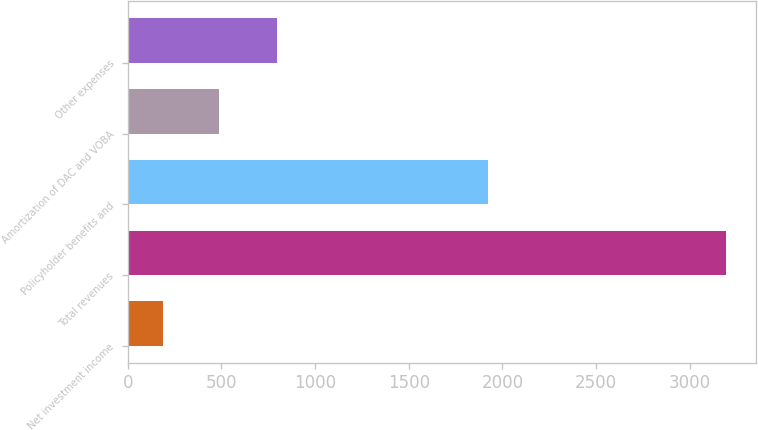Convert chart to OTSL. <chart><loc_0><loc_0><loc_500><loc_500><bar_chart><fcel>Net investment income<fcel>Total revenues<fcel>Policyholder benefits and<fcel>Amortization of DAC and VOBA<fcel>Other expenses<nl><fcel>186<fcel>3195<fcel>1924<fcel>486.9<fcel>794<nl></chart> 